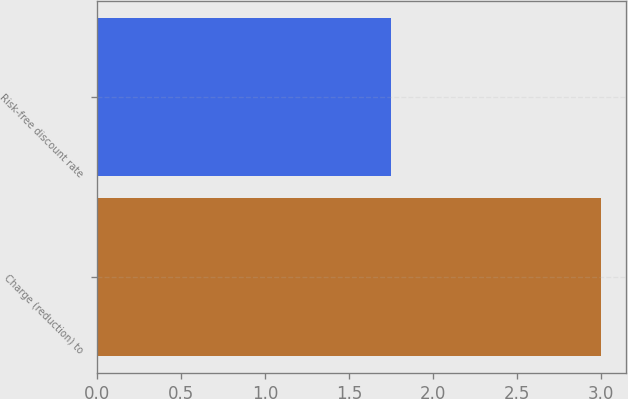Convert chart. <chart><loc_0><loc_0><loc_500><loc_500><bar_chart><fcel>Charge (reduction) to<fcel>Risk-free discount rate<nl><fcel>3<fcel>1.75<nl></chart> 